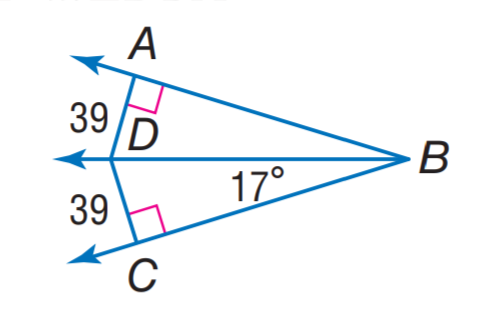Question: Find m \angle D B A.
Choices:
A. 17
B. 22
C. 32
D. 39
Answer with the letter. Answer: A 